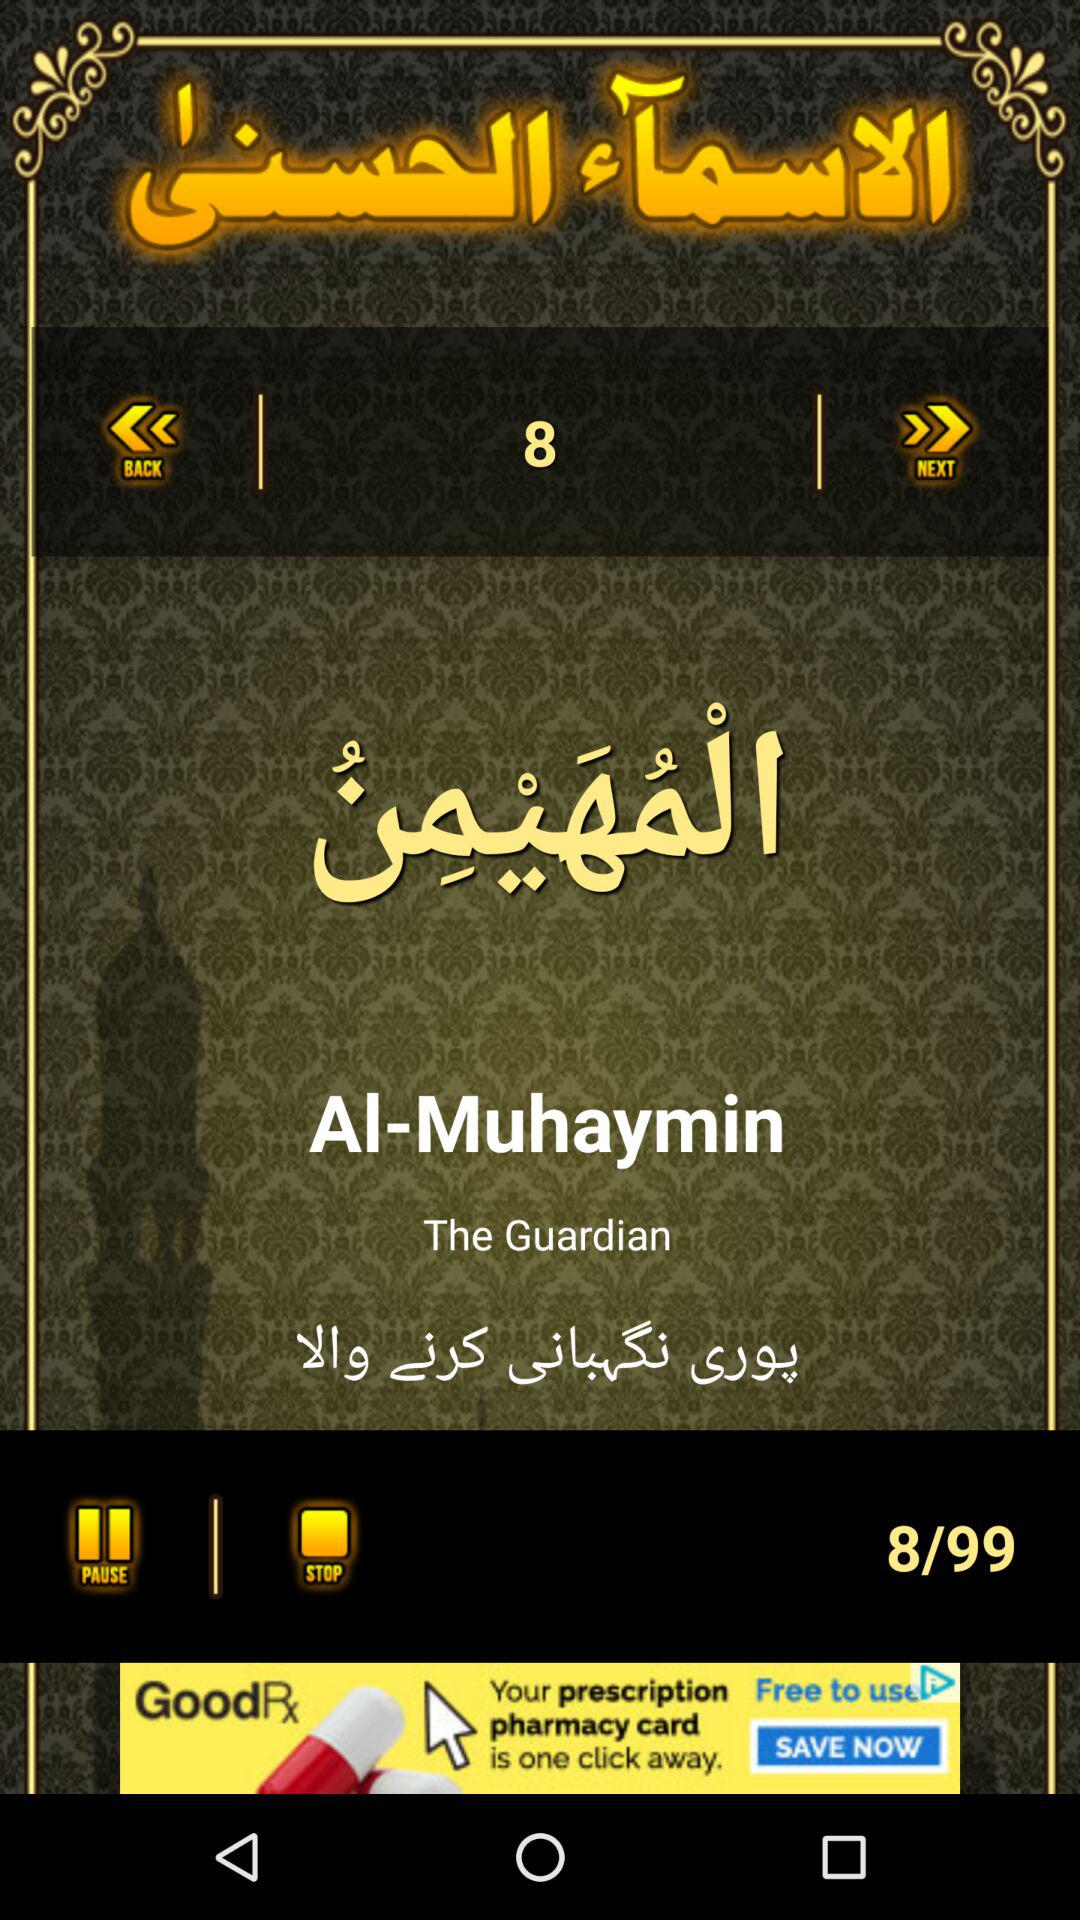What is the total number of songs? The total number of songs is 99. 